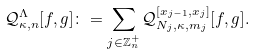<formula> <loc_0><loc_0><loc_500><loc_500>\mathcal { Q } _ { \kappa , n } ^ { \Lambda } [ f , g ] \colon = \sum _ { j \in \mathbb { Z } _ { n } ^ { + } } \mathcal { Q } _ { N _ { j } , \kappa , m _ { j } } ^ { [ x _ { j - 1 } , x _ { j } ] } [ f , g ] .</formula> 